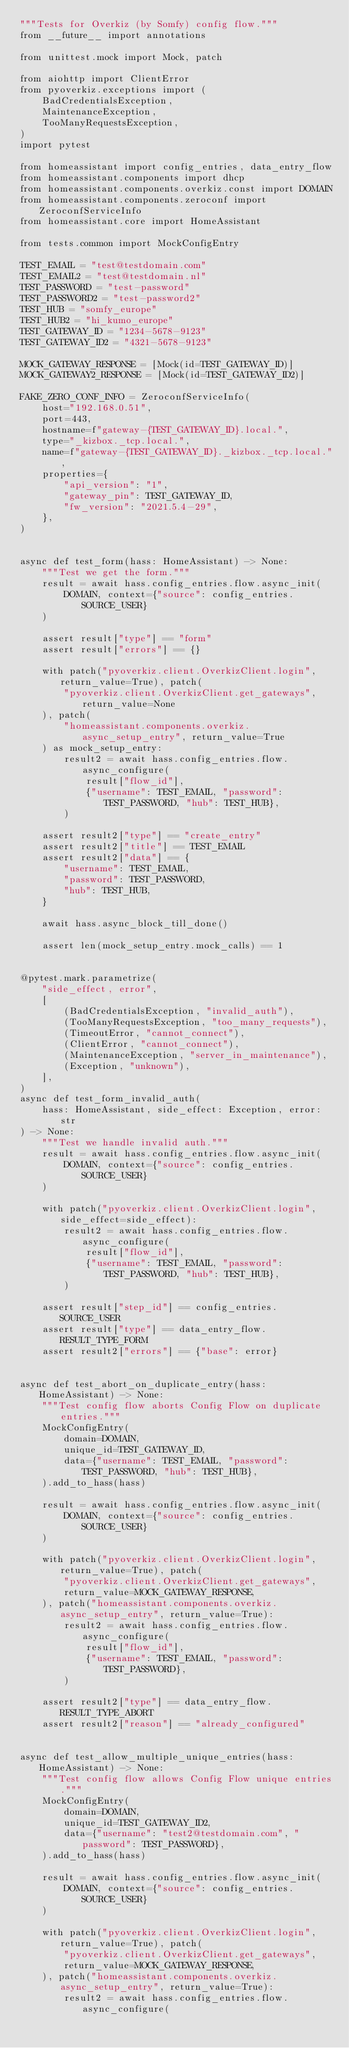Convert code to text. <code><loc_0><loc_0><loc_500><loc_500><_Python_>"""Tests for Overkiz (by Somfy) config flow."""
from __future__ import annotations

from unittest.mock import Mock, patch

from aiohttp import ClientError
from pyoverkiz.exceptions import (
    BadCredentialsException,
    MaintenanceException,
    TooManyRequestsException,
)
import pytest

from homeassistant import config_entries, data_entry_flow
from homeassistant.components import dhcp
from homeassistant.components.overkiz.const import DOMAIN
from homeassistant.components.zeroconf import ZeroconfServiceInfo
from homeassistant.core import HomeAssistant

from tests.common import MockConfigEntry

TEST_EMAIL = "test@testdomain.com"
TEST_EMAIL2 = "test@testdomain.nl"
TEST_PASSWORD = "test-password"
TEST_PASSWORD2 = "test-password2"
TEST_HUB = "somfy_europe"
TEST_HUB2 = "hi_kumo_europe"
TEST_GATEWAY_ID = "1234-5678-9123"
TEST_GATEWAY_ID2 = "4321-5678-9123"

MOCK_GATEWAY_RESPONSE = [Mock(id=TEST_GATEWAY_ID)]
MOCK_GATEWAY2_RESPONSE = [Mock(id=TEST_GATEWAY_ID2)]

FAKE_ZERO_CONF_INFO = ZeroconfServiceInfo(
    host="192.168.0.51",
    port=443,
    hostname=f"gateway-{TEST_GATEWAY_ID}.local.",
    type="_kizbox._tcp.local.",
    name=f"gateway-{TEST_GATEWAY_ID}._kizbox._tcp.local.",
    properties={
        "api_version": "1",
        "gateway_pin": TEST_GATEWAY_ID,
        "fw_version": "2021.5.4-29",
    },
)


async def test_form(hass: HomeAssistant) -> None:
    """Test we get the form."""
    result = await hass.config_entries.flow.async_init(
        DOMAIN, context={"source": config_entries.SOURCE_USER}
    )

    assert result["type"] == "form"
    assert result["errors"] == {}

    with patch("pyoverkiz.client.OverkizClient.login", return_value=True), patch(
        "pyoverkiz.client.OverkizClient.get_gateways", return_value=None
    ), patch(
        "homeassistant.components.overkiz.async_setup_entry", return_value=True
    ) as mock_setup_entry:
        result2 = await hass.config_entries.flow.async_configure(
            result["flow_id"],
            {"username": TEST_EMAIL, "password": TEST_PASSWORD, "hub": TEST_HUB},
        )

    assert result2["type"] == "create_entry"
    assert result2["title"] == TEST_EMAIL
    assert result2["data"] == {
        "username": TEST_EMAIL,
        "password": TEST_PASSWORD,
        "hub": TEST_HUB,
    }

    await hass.async_block_till_done()

    assert len(mock_setup_entry.mock_calls) == 1


@pytest.mark.parametrize(
    "side_effect, error",
    [
        (BadCredentialsException, "invalid_auth"),
        (TooManyRequestsException, "too_many_requests"),
        (TimeoutError, "cannot_connect"),
        (ClientError, "cannot_connect"),
        (MaintenanceException, "server_in_maintenance"),
        (Exception, "unknown"),
    ],
)
async def test_form_invalid_auth(
    hass: HomeAssistant, side_effect: Exception, error: str
) -> None:
    """Test we handle invalid auth."""
    result = await hass.config_entries.flow.async_init(
        DOMAIN, context={"source": config_entries.SOURCE_USER}
    )

    with patch("pyoverkiz.client.OverkizClient.login", side_effect=side_effect):
        result2 = await hass.config_entries.flow.async_configure(
            result["flow_id"],
            {"username": TEST_EMAIL, "password": TEST_PASSWORD, "hub": TEST_HUB},
        )

    assert result["step_id"] == config_entries.SOURCE_USER
    assert result["type"] == data_entry_flow.RESULT_TYPE_FORM
    assert result2["errors"] == {"base": error}


async def test_abort_on_duplicate_entry(hass: HomeAssistant) -> None:
    """Test config flow aborts Config Flow on duplicate entries."""
    MockConfigEntry(
        domain=DOMAIN,
        unique_id=TEST_GATEWAY_ID,
        data={"username": TEST_EMAIL, "password": TEST_PASSWORD, "hub": TEST_HUB},
    ).add_to_hass(hass)

    result = await hass.config_entries.flow.async_init(
        DOMAIN, context={"source": config_entries.SOURCE_USER}
    )

    with patch("pyoverkiz.client.OverkizClient.login", return_value=True), patch(
        "pyoverkiz.client.OverkizClient.get_gateways",
        return_value=MOCK_GATEWAY_RESPONSE,
    ), patch("homeassistant.components.overkiz.async_setup_entry", return_value=True):
        result2 = await hass.config_entries.flow.async_configure(
            result["flow_id"],
            {"username": TEST_EMAIL, "password": TEST_PASSWORD},
        )

    assert result2["type"] == data_entry_flow.RESULT_TYPE_ABORT
    assert result2["reason"] == "already_configured"


async def test_allow_multiple_unique_entries(hass: HomeAssistant) -> None:
    """Test config flow allows Config Flow unique entries."""
    MockConfigEntry(
        domain=DOMAIN,
        unique_id=TEST_GATEWAY_ID2,
        data={"username": "test2@testdomain.com", "password": TEST_PASSWORD},
    ).add_to_hass(hass)

    result = await hass.config_entries.flow.async_init(
        DOMAIN, context={"source": config_entries.SOURCE_USER}
    )

    with patch("pyoverkiz.client.OverkizClient.login", return_value=True), patch(
        "pyoverkiz.client.OverkizClient.get_gateways",
        return_value=MOCK_GATEWAY_RESPONSE,
    ), patch("homeassistant.components.overkiz.async_setup_entry", return_value=True):
        result2 = await hass.config_entries.flow.async_configure(</code> 